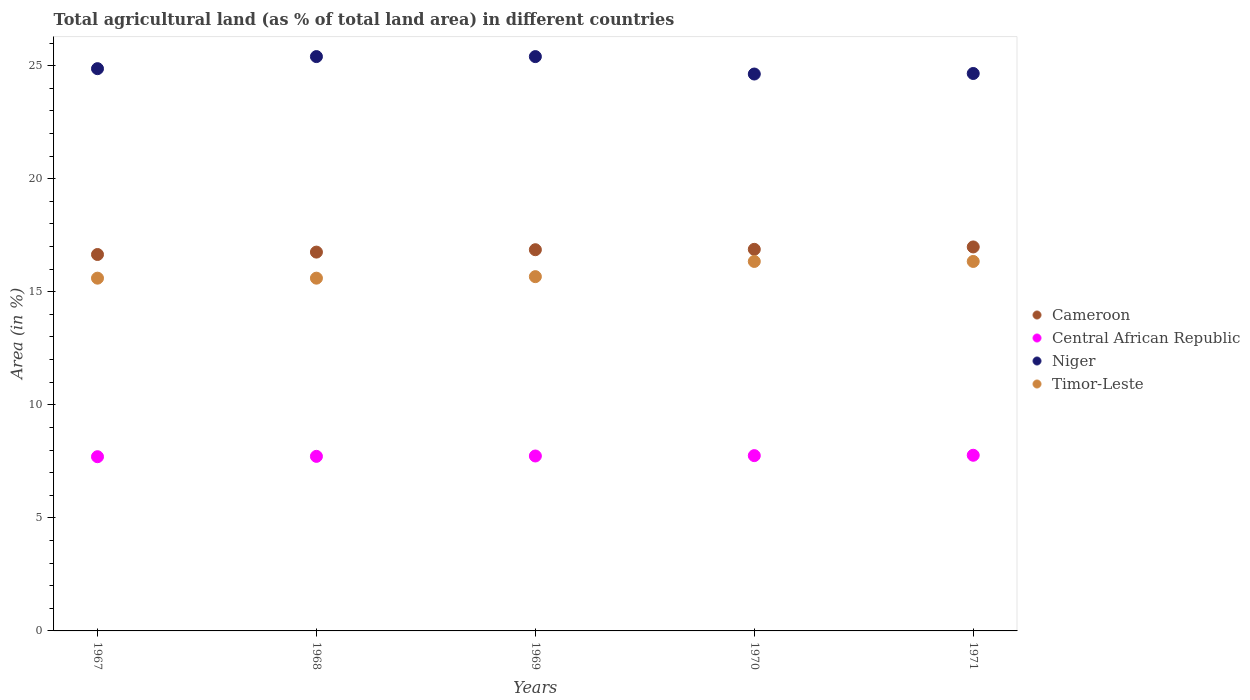What is the percentage of agricultural land in Timor-Leste in 1968?
Give a very brief answer. 15.6. Across all years, what is the maximum percentage of agricultural land in Niger?
Give a very brief answer. 25.4. Across all years, what is the minimum percentage of agricultural land in Niger?
Make the answer very short. 24.63. In which year was the percentage of agricultural land in Central African Republic maximum?
Make the answer very short. 1971. In which year was the percentage of agricultural land in Central African Republic minimum?
Offer a very short reply. 1967. What is the total percentage of agricultural land in Central African Republic in the graph?
Ensure brevity in your answer.  38.69. What is the difference between the percentage of agricultural land in Timor-Leste in 1968 and that in 1969?
Offer a terse response. -0.07. What is the difference between the percentage of agricultural land in Central African Republic in 1969 and the percentage of agricultural land in Timor-Leste in 1970?
Offer a terse response. -8.6. What is the average percentage of agricultural land in Niger per year?
Give a very brief answer. 24.99. In the year 1968, what is the difference between the percentage of agricultural land in Niger and percentage of agricultural land in Timor-Leste?
Your answer should be compact. 9.8. In how many years, is the percentage of agricultural land in Niger greater than 9 %?
Your answer should be compact. 5. What is the ratio of the percentage of agricultural land in Niger in 1968 to that in 1971?
Make the answer very short. 1.03. Is the difference between the percentage of agricultural land in Niger in 1967 and 1970 greater than the difference between the percentage of agricultural land in Timor-Leste in 1967 and 1970?
Your response must be concise. Yes. What is the difference between the highest and the second highest percentage of agricultural land in Central African Republic?
Provide a short and direct response. 0.02. What is the difference between the highest and the lowest percentage of agricultural land in Niger?
Make the answer very short. 0.77. In how many years, is the percentage of agricultural land in Niger greater than the average percentage of agricultural land in Niger taken over all years?
Offer a terse response. 2. Is the sum of the percentage of agricultural land in Niger in 1967 and 1969 greater than the maximum percentage of agricultural land in Central African Republic across all years?
Provide a short and direct response. Yes. Is it the case that in every year, the sum of the percentage of agricultural land in Niger and percentage of agricultural land in Timor-Leste  is greater than the sum of percentage of agricultural land in Cameroon and percentage of agricultural land in Central African Republic?
Provide a succinct answer. Yes. Is it the case that in every year, the sum of the percentage of agricultural land in Timor-Leste and percentage of agricultural land in Niger  is greater than the percentage of agricultural land in Cameroon?
Keep it short and to the point. Yes. How many dotlines are there?
Offer a terse response. 4. What is the difference between two consecutive major ticks on the Y-axis?
Provide a short and direct response. 5. Are the values on the major ticks of Y-axis written in scientific E-notation?
Your answer should be very brief. No. Does the graph contain any zero values?
Make the answer very short. No. Where does the legend appear in the graph?
Offer a terse response. Center right. What is the title of the graph?
Offer a terse response. Total agricultural land (as % of total land area) in different countries. Does "OECD members" appear as one of the legend labels in the graph?
Provide a short and direct response. No. What is the label or title of the X-axis?
Offer a terse response. Years. What is the label or title of the Y-axis?
Provide a short and direct response. Area (in %). What is the Area (in %) in Cameroon in 1967?
Your answer should be compact. 16.65. What is the Area (in %) in Central African Republic in 1967?
Provide a short and direct response. 7.7. What is the Area (in %) of Niger in 1967?
Offer a terse response. 24.87. What is the Area (in %) of Timor-Leste in 1967?
Ensure brevity in your answer.  15.6. What is the Area (in %) in Cameroon in 1968?
Your response must be concise. 16.75. What is the Area (in %) of Central African Republic in 1968?
Provide a succinct answer. 7.72. What is the Area (in %) in Niger in 1968?
Ensure brevity in your answer.  25.4. What is the Area (in %) in Timor-Leste in 1968?
Make the answer very short. 15.6. What is the Area (in %) of Cameroon in 1969?
Keep it short and to the point. 16.86. What is the Area (in %) in Central African Republic in 1969?
Your answer should be very brief. 7.74. What is the Area (in %) of Niger in 1969?
Ensure brevity in your answer.  25.4. What is the Area (in %) of Timor-Leste in 1969?
Keep it short and to the point. 15.67. What is the Area (in %) of Cameroon in 1970?
Your answer should be very brief. 16.88. What is the Area (in %) of Central African Republic in 1970?
Offer a terse response. 7.75. What is the Area (in %) in Niger in 1970?
Provide a short and direct response. 24.63. What is the Area (in %) of Timor-Leste in 1970?
Your answer should be compact. 16.34. What is the Area (in %) of Cameroon in 1971?
Your response must be concise. 16.98. What is the Area (in %) in Central African Republic in 1971?
Ensure brevity in your answer.  7.77. What is the Area (in %) in Niger in 1971?
Provide a succinct answer. 24.65. What is the Area (in %) of Timor-Leste in 1971?
Give a very brief answer. 16.34. Across all years, what is the maximum Area (in %) of Cameroon?
Give a very brief answer. 16.98. Across all years, what is the maximum Area (in %) in Central African Republic?
Your response must be concise. 7.77. Across all years, what is the maximum Area (in %) of Niger?
Your answer should be compact. 25.4. Across all years, what is the maximum Area (in %) of Timor-Leste?
Your answer should be very brief. 16.34. Across all years, what is the minimum Area (in %) of Cameroon?
Ensure brevity in your answer.  16.65. Across all years, what is the minimum Area (in %) in Central African Republic?
Offer a very short reply. 7.7. Across all years, what is the minimum Area (in %) in Niger?
Offer a very short reply. 24.63. Across all years, what is the minimum Area (in %) of Timor-Leste?
Ensure brevity in your answer.  15.6. What is the total Area (in %) in Cameroon in the graph?
Provide a short and direct response. 84.12. What is the total Area (in %) in Central African Republic in the graph?
Your answer should be very brief. 38.69. What is the total Area (in %) of Niger in the graph?
Your response must be concise. 124.96. What is the total Area (in %) of Timor-Leste in the graph?
Provide a short and direct response. 79.56. What is the difference between the Area (in %) in Cameroon in 1967 and that in 1968?
Give a very brief answer. -0.11. What is the difference between the Area (in %) in Central African Republic in 1967 and that in 1968?
Your answer should be compact. -0.02. What is the difference between the Area (in %) in Niger in 1967 and that in 1968?
Your response must be concise. -0.53. What is the difference between the Area (in %) in Cameroon in 1967 and that in 1969?
Provide a short and direct response. -0.21. What is the difference between the Area (in %) of Central African Republic in 1967 and that in 1969?
Your answer should be very brief. -0.03. What is the difference between the Area (in %) of Niger in 1967 and that in 1969?
Ensure brevity in your answer.  -0.53. What is the difference between the Area (in %) in Timor-Leste in 1967 and that in 1969?
Your response must be concise. -0.07. What is the difference between the Area (in %) of Cameroon in 1967 and that in 1970?
Make the answer very short. -0.23. What is the difference between the Area (in %) in Central African Republic in 1967 and that in 1970?
Your answer should be compact. -0.05. What is the difference between the Area (in %) in Niger in 1967 and that in 1970?
Ensure brevity in your answer.  0.24. What is the difference between the Area (in %) in Timor-Leste in 1967 and that in 1970?
Give a very brief answer. -0.74. What is the difference between the Area (in %) of Cameroon in 1967 and that in 1971?
Your response must be concise. -0.33. What is the difference between the Area (in %) of Central African Republic in 1967 and that in 1971?
Your answer should be very brief. -0.06. What is the difference between the Area (in %) of Niger in 1967 and that in 1971?
Offer a very short reply. 0.21. What is the difference between the Area (in %) in Timor-Leste in 1967 and that in 1971?
Keep it short and to the point. -0.74. What is the difference between the Area (in %) in Cameroon in 1968 and that in 1969?
Ensure brevity in your answer.  -0.11. What is the difference between the Area (in %) in Central African Republic in 1968 and that in 1969?
Offer a very short reply. -0.02. What is the difference between the Area (in %) of Niger in 1968 and that in 1969?
Keep it short and to the point. 0. What is the difference between the Area (in %) of Timor-Leste in 1968 and that in 1969?
Offer a terse response. -0.07. What is the difference between the Area (in %) in Cameroon in 1968 and that in 1970?
Your answer should be compact. -0.12. What is the difference between the Area (in %) in Central African Republic in 1968 and that in 1970?
Offer a very short reply. -0.03. What is the difference between the Area (in %) of Niger in 1968 and that in 1970?
Your answer should be very brief. 0.77. What is the difference between the Area (in %) of Timor-Leste in 1968 and that in 1970?
Your answer should be very brief. -0.74. What is the difference between the Area (in %) in Cameroon in 1968 and that in 1971?
Your answer should be compact. -0.23. What is the difference between the Area (in %) of Central African Republic in 1968 and that in 1971?
Your response must be concise. -0.05. What is the difference between the Area (in %) in Niger in 1968 and that in 1971?
Make the answer very short. 0.75. What is the difference between the Area (in %) in Timor-Leste in 1968 and that in 1971?
Your response must be concise. -0.74. What is the difference between the Area (in %) in Cameroon in 1969 and that in 1970?
Your answer should be very brief. -0.02. What is the difference between the Area (in %) of Central African Republic in 1969 and that in 1970?
Provide a succinct answer. -0.02. What is the difference between the Area (in %) of Niger in 1969 and that in 1970?
Offer a very short reply. 0.77. What is the difference between the Area (in %) of Timor-Leste in 1969 and that in 1970?
Your response must be concise. -0.67. What is the difference between the Area (in %) of Cameroon in 1969 and that in 1971?
Provide a succinct answer. -0.12. What is the difference between the Area (in %) in Central African Republic in 1969 and that in 1971?
Your response must be concise. -0.03. What is the difference between the Area (in %) of Niger in 1969 and that in 1971?
Ensure brevity in your answer.  0.75. What is the difference between the Area (in %) of Timor-Leste in 1969 and that in 1971?
Your answer should be compact. -0.67. What is the difference between the Area (in %) in Cameroon in 1970 and that in 1971?
Your answer should be very brief. -0.11. What is the difference between the Area (in %) of Central African Republic in 1970 and that in 1971?
Make the answer very short. -0.02. What is the difference between the Area (in %) in Niger in 1970 and that in 1971?
Your answer should be very brief. -0.02. What is the difference between the Area (in %) of Cameroon in 1967 and the Area (in %) of Central African Republic in 1968?
Provide a succinct answer. 8.93. What is the difference between the Area (in %) of Cameroon in 1967 and the Area (in %) of Niger in 1968?
Your answer should be very brief. -8.75. What is the difference between the Area (in %) of Cameroon in 1967 and the Area (in %) of Timor-Leste in 1968?
Keep it short and to the point. 1.05. What is the difference between the Area (in %) of Central African Republic in 1967 and the Area (in %) of Niger in 1968?
Make the answer very short. -17.7. What is the difference between the Area (in %) of Central African Republic in 1967 and the Area (in %) of Timor-Leste in 1968?
Your response must be concise. -7.9. What is the difference between the Area (in %) of Niger in 1967 and the Area (in %) of Timor-Leste in 1968?
Give a very brief answer. 9.27. What is the difference between the Area (in %) of Cameroon in 1967 and the Area (in %) of Central African Republic in 1969?
Offer a very short reply. 8.91. What is the difference between the Area (in %) in Cameroon in 1967 and the Area (in %) in Niger in 1969?
Give a very brief answer. -8.75. What is the difference between the Area (in %) in Cameroon in 1967 and the Area (in %) in Timor-Leste in 1969?
Your answer should be compact. 0.98. What is the difference between the Area (in %) of Central African Republic in 1967 and the Area (in %) of Niger in 1969?
Ensure brevity in your answer.  -17.7. What is the difference between the Area (in %) of Central African Republic in 1967 and the Area (in %) of Timor-Leste in 1969?
Ensure brevity in your answer.  -7.96. What is the difference between the Area (in %) of Niger in 1967 and the Area (in %) of Timor-Leste in 1969?
Ensure brevity in your answer.  9.2. What is the difference between the Area (in %) of Cameroon in 1967 and the Area (in %) of Central African Republic in 1970?
Your answer should be very brief. 8.9. What is the difference between the Area (in %) of Cameroon in 1967 and the Area (in %) of Niger in 1970?
Keep it short and to the point. -7.98. What is the difference between the Area (in %) of Cameroon in 1967 and the Area (in %) of Timor-Leste in 1970?
Ensure brevity in your answer.  0.31. What is the difference between the Area (in %) of Central African Republic in 1967 and the Area (in %) of Niger in 1970?
Offer a terse response. -16.93. What is the difference between the Area (in %) in Central African Republic in 1967 and the Area (in %) in Timor-Leste in 1970?
Keep it short and to the point. -8.64. What is the difference between the Area (in %) in Niger in 1967 and the Area (in %) in Timor-Leste in 1970?
Provide a short and direct response. 8.53. What is the difference between the Area (in %) of Cameroon in 1967 and the Area (in %) of Central African Republic in 1971?
Provide a succinct answer. 8.88. What is the difference between the Area (in %) of Cameroon in 1967 and the Area (in %) of Niger in 1971?
Make the answer very short. -8.01. What is the difference between the Area (in %) of Cameroon in 1967 and the Area (in %) of Timor-Leste in 1971?
Give a very brief answer. 0.31. What is the difference between the Area (in %) of Central African Republic in 1967 and the Area (in %) of Niger in 1971?
Your response must be concise. -16.95. What is the difference between the Area (in %) in Central African Republic in 1967 and the Area (in %) in Timor-Leste in 1971?
Give a very brief answer. -8.64. What is the difference between the Area (in %) in Niger in 1967 and the Area (in %) in Timor-Leste in 1971?
Your answer should be compact. 8.53. What is the difference between the Area (in %) of Cameroon in 1968 and the Area (in %) of Central African Republic in 1969?
Provide a succinct answer. 9.02. What is the difference between the Area (in %) in Cameroon in 1968 and the Area (in %) in Niger in 1969?
Keep it short and to the point. -8.65. What is the difference between the Area (in %) in Cameroon in 1968 and the Area (in %) in Timor-Leste in 1969?
Your answer should be compact. 1.09. What is the difference between the Area (in %) in Central African Republic in 1968 and the Area (in %) in Niger in 1969?
Ensure brevity in your answer.  -17.68. What is the difference between the Area (in %) of Central African Republic in 1968 and the Area (in %) of Timor-Leste in 1969?
Offer a very short reply. -7.95. What is the difference between the Area (in %) in Niger in 1968 and the Area (in %) in Timor-Leste in 1969?
Your answer should be very brief. 9.73. What is the difference between the Area (in %) in Cameroon in 1968 and the Area (in %) in Central African Republic in 1970?
Provide a short and direct response. 9. What is the difference between the Area (in %) of Cameroon in 1968 and the Area (in %) of Niger in 1970?
Your answer should be very brief. -7.88. What is the difference between the Area (in %) of Cameroon in 1968 and the Area (in %) of Timor-Leste in 1970?
Your response must be concise. 0.41. What is the difference between the Area (in %) of Central African Republic in 1968 and the Area (in %) of Niger in 1970?
Your answer should be compact. -16.91. What is the difference between the Area (in %) in Central African Republic in 1968 and the Area (in %) in Timor-Leste in 1970?
Your answer should be compact. -8.62. What is the difference between the Area (in %) of Niger in 1968 and the Area (in %) of Timor-Leste in 1970?
Make the answer very short. 9.06. What is the difference between the Area (in %) of Cameroon in 1968 and the Area (in %) of Central African Republic in 1971?
Provide a succinct answer. 8.99. What is the difference between the Area (in %) of Cameroon in 1968 and the Area (in %) of Niger in 1971?
Ensure brevity in your answer.  -7.9. What is the difference between the Area (in %) of Cameroon in 1968 and the Area (in %) of Timor-Leste in 1971?
Offer a terse response. 0.41. What is the difference between the Area (in %) of Central African Republic in 1968 and the Area (in %) of Niger in 1971?
Give a very brief answer. -16.93. What is the difference between the Area (in %) of Central African Republic in 1968 and the Area (in %) of Timor-Leste in 1971?
Provide a succinct answer. -8.62. What is the difference between the Area (in %) of Niger in 1968 and the Area (in %) of Timor-Leste in 1971?
Your answer should be very brief. 9.06. What is the difference between the Area (in %) in Cameroon in 1969 and the Area (in %) in Central African Republic in 1970?
Offer a terse response. 9.11. What is the difference between the Area (in %) in Cameroon in 1969 and the Area (in %) in Niger in 1970?
Offer a very short reply. -7.77. What is the difference between the Area (in %) of Cameroon in 1969 and the Area (in %) of Timor-Leste in 1970?
Your response must be concise. 0.52. What is the difference between the Area (in %) in Central African Republic in 1969 and the Area (in %) in Niger in 1970?
Provide a short and direct response. -16.89. What is the difference between the Area (in %) in Central African Republic in 1969 and the Area (in %) in Timor-Leste in 1970?
Give a very brief answer. -8.6. What is the difference between the Area (in %) in Niger in 1969 and the Area (in %) in Timor-Leste in 1970?
Offer a very short reply. 9.06. What is the difference between the Area (in %) in Cameroon in 1969 and the Area (in %) in Central African Republic in 1971?
Your response must be concise. 9.09. What is the difference between the Area (in %) in Cameroon in 1969 and the Area (in %) in Niger in 1971?
Offer a very short reply. -7.79. What is the difference between the Area (in %) of Cameroon in 1969 and the Area (in %) of Timor-Leste in 1971?
Provide a short and direct response. 0.52. What is the difference between the Area (in %) in Central African Republic in 1969 and the Area (in %) in Niger in 1971?
Your answer should be compact. -16.92. What is the difference between the Area (in %) of Central African Republic in 1969 and the Area (in %) of Timor-Leste in 1971?
Give a very brief answer. -8.6. What is the difference between the Area (in %) in Niger in 1969 and the Area (in %) in Timor-Leste in 1971?
Your response must be concise. 9.06. What is the difference between the Area (in %) of Cameroon in 1970 and the Area (in %) of Central African Republic in 1971?
Keep it short and to the point. 9.11. What is the difference between the Area (in %) of Cameroon in 1970 and the Area (in %) of Niger in 1971?
Your answer should be compact. -7.78. What is the difference between the Area (in %) of Cameroon in 1970 and the Area (in %) of Timor-Leste in 1971?
Offer a terse response. 0.54. What is the difference between the Area (in %) in Central African Republic in 1970 and the Area (in %) in Niger in 1971?
Keep it short and to the point. -16.9. What is the difference between the Area (in %) in Central African Republic in 1970 and the Area (in %) in Timor-Leste in 1971?
Make the answer very short. -8.59. What is the difference between the Area (in %) of Niger in 1970 and the Area (in %) of Timor-Leste in 1971?
Keep it short and to the point. 8.29. What is the average Area (in %) in Cameroon per year?
Give a very brief answer. 16.82. What is the average Area (in %) in Central African Republic per year?
Your answer should be compact. 7.74. What is the average Area (in %) in Niger per year?
Your response must be concise. 24.99. What is the average Area (in %) in Timor-Leste per year?
Give a very brief answer. 15.91. In the year 1967, what is the difference between the Area (in %) of Cameroon and Area (in %) of Central African Republic?
Provide a succinct answer. 8.94. In the year 1967, what is the difference between the Area (in %) in Cameroon and Area (in %) in Niger?
Your response must be concise. -8.22. In the year 1967, what is the difference between the Area (in %) of Cameroon and Area (in %) of Timor-Leste?
Ensure brevity in your answer.  1.05. In the year 1967, what is the difference between the Area (in %) in Central African Republic and Area (in %) in Niger?
Ensure brevity in your answer.  -17.16. In the year 1967, what is the difference between the Area (in %) in Central African Republic and Area (in %) in Timor-Leste?
Ensure brevity in your answer.  -7.9. In the year 1967, what is the difference between the Area (in %) in Niger and Area (in %) in Timor-Leste?
Ensure brevity in your answer.  9.27. In the year 1968, what is the difference between the Area (in %) of Cameroon and Area (in %) of Central African Republic?
Your answer should be compact. 9.03. In the year 1968, what is the difference between the Area (in %) of Cameroon and Area (in %) of Niger?
Ensure brevity in your answer.  -8.65. In the year 1968, what is the difference between the Area (in %) in Cameroon and Area (in %) in Timor-Leste?
Make the answer very short. 1.15. In the year 1968, what is the difference between the Area (in %) in Central African Republic and Area (in %) in Niger?
Ensure brevity in your answer.  -17.68. In the year 1968, what is the difference between the Area (in %) of Central African Republic and Area (in %) of Timor-Leste?
Provide a short and direct response. -7.88. In the year 1968, what is the difference between the Area (in %) of Niger and Area (in %) of Timor-Leste?
Keep it short and to the point. 9.8. In the year 1969, what is the difference between the Area (in %) in Cameroon and Area (in %) in Central African Republic?
Provide a succinct answer. 9.12. In the year 1969, what is the difference between the Area (in %) in Cameroon and Area (in %) in Niger?
Provide a short and direct response. -8.54. In the year 1969, what is the difference between the Area (in %) in Cameroon and Area (in %) in Timor-Leste?
Your answer should be compact. 1.19. In the year 1969, what is the difference between the Area (in %) in Central African Republic and Area (in %) in Niger?
Provide a succinct answer. -17.66. In the year 1969, what is the difference between the Area (in %) of Central African Republic and Area (in %) of Timor-Leste?
Offer a terse response. -7.93. In the year 1969, what is the difference between the Area (in %) in Niger and Area (in %) in Timor-Leste?
Your answer should be very brief. 9.73. In the year 1970, what is the difference between the Area (in %) in Cameroon and Area (in %) in Central African Republic?
Your answer should be compact. 9.12. In the year 1970, what is the difference between the Area (in %) in Cameroon and Area (in %) in Niger?
Offer a terse response. -7.75. In the year 1970, what is the difference between the Area (in %) in Cameroon and Area (in %) in Timor-Leste?
Provide a succinct answer. 0.54. In the year 1970, what is the difference between the Area (in %) of Central African Republic and Area (in %) of Niger?
Make the answer very short. -16.88. In the year 1970, what is the difference between the Area (in %) of Central African Republic and Area (in %) of Timor-Leste?
Ensure brevity in your answer.  -8.59. In the year 1970, what is the difference between the Area (in %) in Niger and Area (in %) in Timor-Leste?
Offer a very short reply. 8.29. In the year 1971, what is the difference between the Area (in %) in Cameroon and Area (in %) in Central African Republic?
Offer a very short reply. 9.21. In the year 1971, what is the difference between the Area (in %) of Cameroon and Area (in %) of Niger?
Offer a very short reply. -7.67. In the year 1971, what is the difference between the Area (in %) of Cameroon and Area (in %) of Timor-Leste?
Provide a succinct answer. 0.64. In the year 1971, what is the difference between the Area (in %) of Central African Republic and Area (in %) of Niger?
Offer a very short reply. -16.89. In the year 1971, what is the difference between the Area (in %) of Central African Republic and Area (in %) of Timor-Leste?
Offer a terse response. -8.57. In the year 1971, what is the difference between the Area (in %) in Niger and Area (in %) in Timor-Leste?
Provide a short and direct response. 8.31. What is the ratio of the Area (in %) in Central African Republic in 1967 to that in 1968?
Make the answer very short. 1. What is the ratio of the Area (in %) in Timor-Leste in 1967 to that in 1968?
Your response must be concise. 1. What is the ratio of the Area (in %) of Cameroon in 1967 to that in 1969?
Your response must be concise. 0.99. What is the ratio of the Area (in %) of Central African Republic in 1967 to that in 1969?
Provide a succinct answer. 1. What is the ratio of the Area (in %) of Cameroon in 1967 to that in 1970?
Offer a terse response. 0.99. What is the ratio of the Area (in %) in Central African Republic in 1967 to that in 1970?
Keep it short and to the point. 0.99. What is the ratio of the Area (in %) in Niger in 1967 to that in 1970?
Provide a short and direct response. 1.01. What is the ratio of the Area (in %) in Timor-Leste in 1967 to that in 1970?
Your answer should be very brief. 0.95. What is the ratio of the Area (in %) of Cameroon in 1967 to that in 1971?
Your answer should be very brief. 0.98. What is the ratio of the Area (in %) of Central African Republic in 1967 to that in 1971?
Offer a terse response. 0.99. What is the ratio of the Area (in %) of Niger in 1967 to that in 1971?
Offer a terse response. 1.01. What is the ratio of the Area (in %) of Timor-Leste in 1967 to that in 1971?
Give a very brief answer. 0.95. What is the ratio of the Area (in %) in Niger in 1968 to that in 1969?
Offer a very short reply. 1. What is the ratio of the Area (in %) of Niger in 1968 to that in 1970?
Your answer should be very brief. 1.03. What is the ratio of the Area (in %) of Timor-Leste in 1968 to that in 1970?
Give a very brief answer. 0.95. What is the ratio of the Area (in %) of Cameroon in 1968 to that in 1971?
Make the answer very short. 0.99. What is the ratio of the Area (in %) in Niger in 1968 to that in 1971?
Ensure brevity in your answer.  1.03. What is the ratio of the Area (in %) of Timor-Leste in 1968 to that in 1971?
Provide a short and direct response. 0.95. What is the ratio of the Area (in %) of Niger in 1969 to that in 1970?
Your response must be concise. 1.03. What is the ratio of the Area (in %) in Timor-Leste in 1969 to that in 1970?
Your answer should be very brief. 0.96. What is the ratio of the Area (in %) of Cameroon in 1969 to that in 1971?
Your answer should be very brief. 0.99. What is the ratio of the Area (in %) in Central African Republic in 1969 to that in 1971?
Provide a succinct answer. 1. What is the ratio of the Area (in %) in Niger in 1969 to that in 1971?
Your answer should be compact. 1.03. What is the ratio of the Area (in %) in Timor-Leste in 1969 to that in 1971?
Give a very brief answer. 0.96. What is the ratio of the Area (in %) in Niger in 1970 to that in 1971?
Offer a very short reply. 1. What is the difference between the highest and the second highest Area (in %) of Cameroon?
Ensure brevity in your answer.  0.11. What is the difference between the highest and the second highest Area (in %) in Central African Republic?
Your answer should be very brief. 0.02. What is the difference between the highest and the second highest Area (in %) of Niger?
Make the answer very short. 0. What is the difference between the highest and the second highest Area (in %) of Timor-Leste?
Offer a terse response. 0. What is the difference between the highest and the lowest Area (in %) of Cameroon?
Give a very brief answer. 0.33. What is the difference between the highest and the lowest Area (in %) of Central African Republic?
Your answer should be compact. 0.06. What is the difference between the highest and the lowest Area (in %) in Niger?
Your answer should be very brief. 0.77. What is the difference between the highest and the lowest Area (in %) in Timor-Leste?
Ensure brevity in your answer.  0.74. 